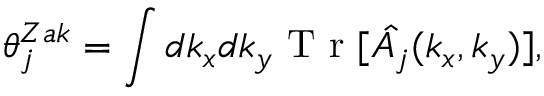Convert formula to latex. <formula><loc_0><loc_0><loc_500><loc_500>\theta _ { j } ^ { Z a k } = \int d k _ { x } d k _ { y } T r [ \hat { A _ { j } } ( k _ { x } , k _ { y } ) ] ,</formula> 